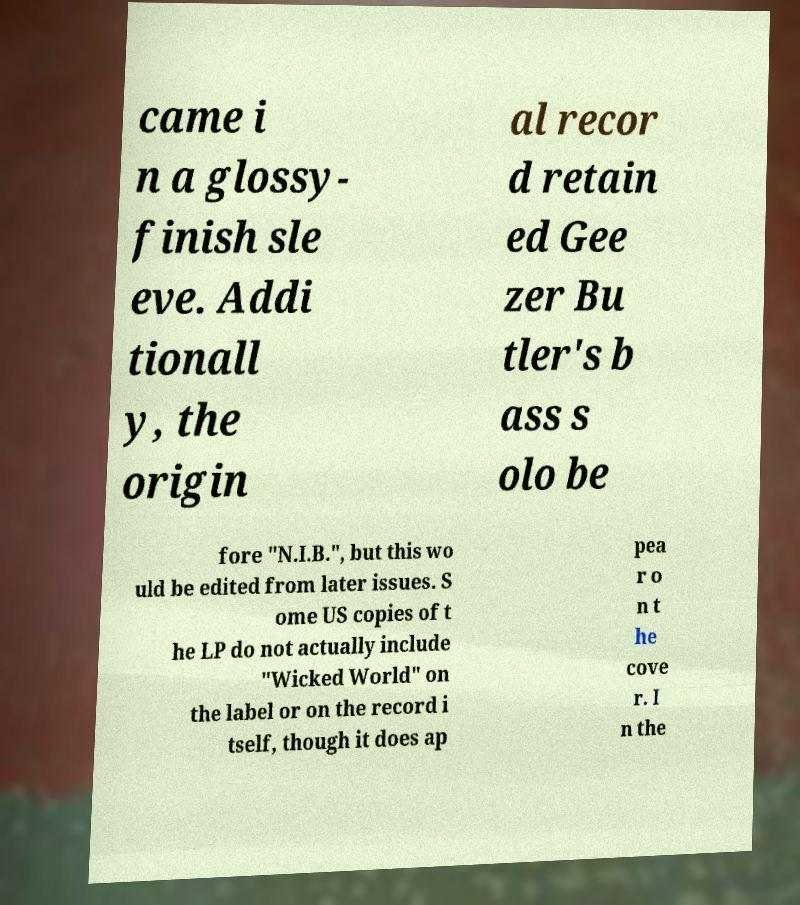I need the written content from this picture converted into text. Can you do that? came i n a glossy- finish sle eve. Addi tionall y, the origin al recor d retain ed Gee zer Bu tler's b ass s olo be fore "N.I.B.", but this wo uld be edited from later issues. S ome US copies of t he LP do not actually include "Wicked World" on the label or on the record i tself, though it does ap pea r o n t he cove r. I n the 